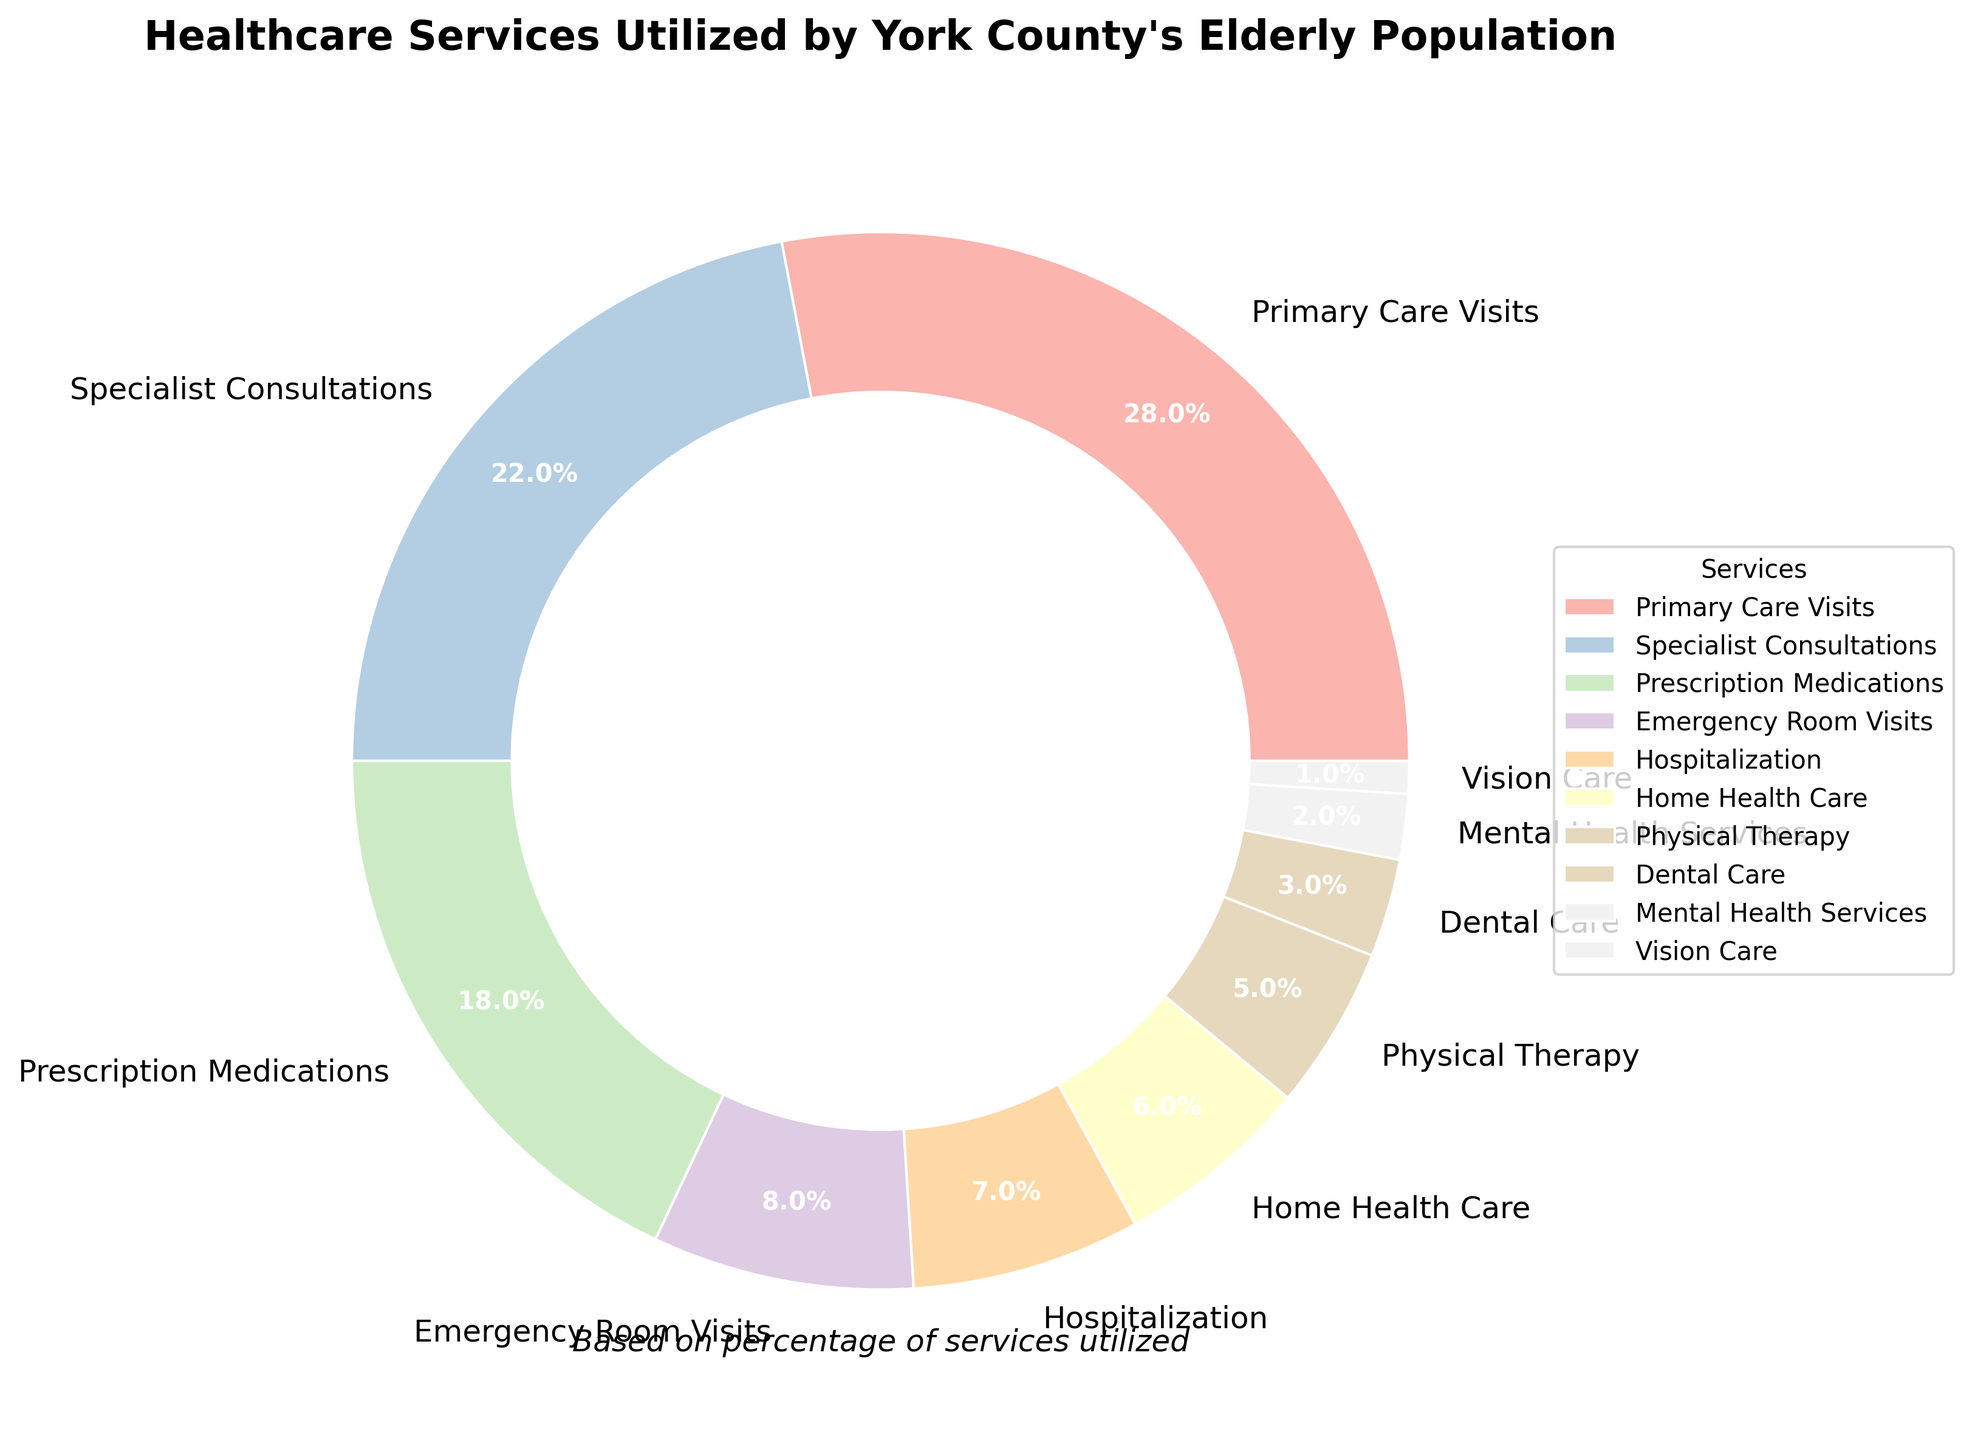Which healthcare service is utilized the most by York County's elderly population? By looking at the pie chart, identify the service with the largest percentage. Primary Care Visits have the highest percentage.
Answer: Primary Care Visits Which service is used more, Specialist Consultations or Prescription Medications? Compare the percentages of Specialist Consultations and Prescription Medications shown in the pie chart. Specialist Consultations have a higher percentage (22%) than Prescription Medications (18%).
Answer: Specialist Consultations Which services together make up 30% of the healthcare services? Look for combinations of services whose percentages add up to 30%. Emergency Room Visits (8%), Hospitalization (7%), Home Health Care (6%), Physical Therapy (5%), and Dental Care (3%) together make up 29%, thus the closest combination is Emergency Room Visits (8%) + Hospitalization (7%) + Home Health Care (6%) + Physical Therapy (5%) + Dental Care (3%).
Answer: Emergency Room Visits, Hospitalization, Home Health Care, Physical Therapy, Dental Care What is the combined percentage of Emergency Room Visits and Hospitalization? Add the percentages of Emergency Room Visits and Hospitalization provided in the chart (8% + 7%).
Answer: 15% Does Dental Care have a higher percentage than Mental Health Services? Compare the percentages of Dental Care (3%) and Mental Health Services (2%). Dental Care has a higher percentage.
Answer: Yes Which services are utilized less than 5% according to the chart? Identify all services in the pie chart with percentages less than 5%. These services are Physical Therapy (5%), Dental Care (3%), Mental Health Services (2%), and Vision Care (1%).
Answer: Dental Care, Mental Health Services, Vision Care Out of Home Health Care, Physical Therapy, and Vision Care, which one has the smallest utilization? Compare the percentages of Home Health Care, Physical Therapy, and Vision Care. Vision Care has the smallest percentage (1%).
Answer: Vision Care Which healthcare service utilizes the pastel blue color in the pie chart? Visually identify which service is marked with pastel blue in the pie chart. Prescription Medications (18%) is marked with pastel blue color.
Answer: Prescription Medications 